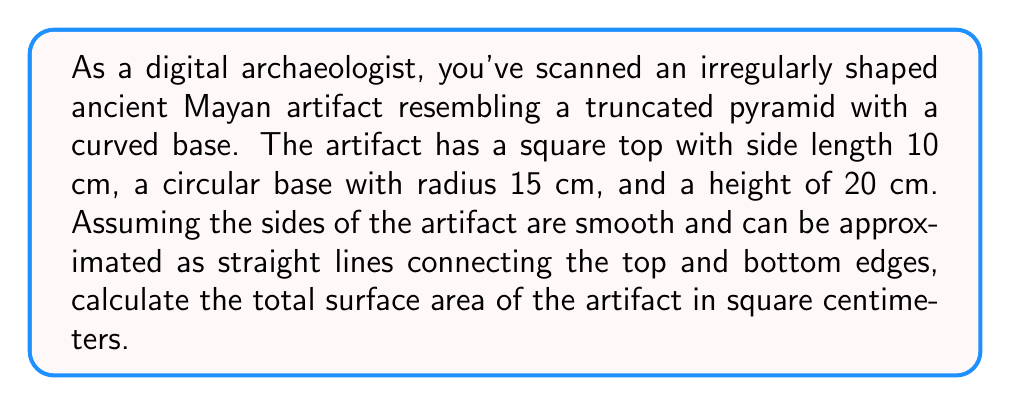Can you solve this math problem? Let's break this down step-by-step:

1. Calculate the area of the square top:
   $A_{top} = 10^2 = 100$ cm²

2. Calculate the area of the circular base:
   $A_{base} = \pi r^2 = \pi (15^2) = 225\pi$ cm²

3. Calculate the lateral surface area:
   To do this, we need to find the slant height and the average perimeter.

   a. Slant height (s):
      Using the Pythagorean theorem:
      $$s = \sqrt{20^2 + (15-5)^2} = \sqrt{400 + 100} = \sqrt{500} = 10\sqrt{5}$$ cm

   b. Average perimeter:
      Top perimeter: $4 * 10 = 40$ cm
      Bottom perimeter: $2\pi r = 2\pi * 15 = 30\pi$ cm
      Average perimeter: $(40 + 30\pi) / 2 = 20 + 15\pi$ cm

   c. Lateral surface area:
      $A_{lateral} = (20 + 15\pi) * 10\sqrt{5}$ cm²

4. Total surface area:
   $A_{total} = A_{top} + A_{base} + A_{lateral}$
   $A_{total} = 100 + 225\pi + (200 + 150\pi)\sqrt{5}$ cm²

   $A_{total} = 100 + 225\pi + 200\sqrt{5} + 150\pi\sqrt{5}$ cm²
Answer: $100 + 225\pi + 200\sqrt{5} + 150\pi\sqrt{5}$ cm² 